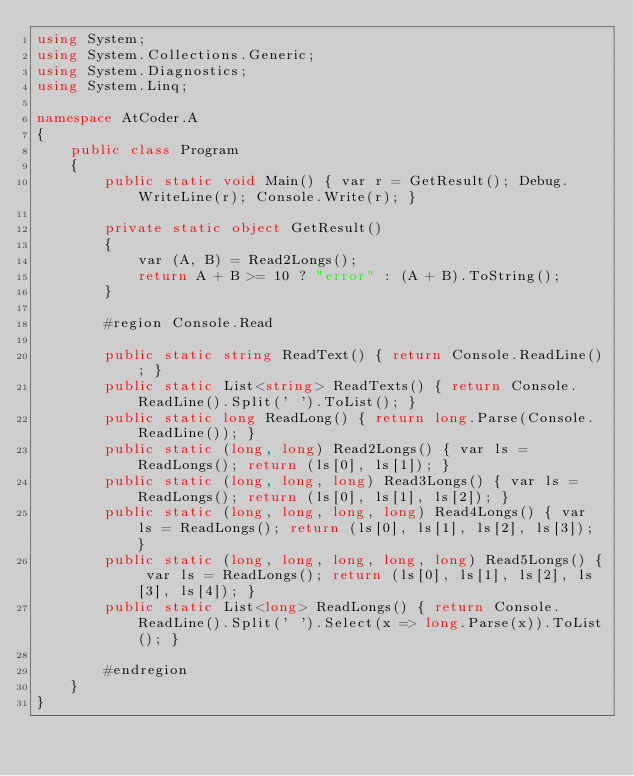Convert code to text. <code><loc_0><loc_0><loc_500><loc_500><_C#_>using System;
using System.Collections.Generic;
using System.Diagnostics;
using System.Linq;

namespace AtCoder.A
{
    public class Program
    {
        public static void Main() { var r = GetResult(); Debug.WriteLine(r); Console.Write(r); }

        private static object GetResult()
        {
            var (A, B) = Read2Longs();
            return A + B >= 10 ? "error" : (A + B).ToString();
        }

        #region Console.Read

        public static string ReadText() { return Console.ReadLine(); }
        public static List<string> ReadTexts() { return Console.ReadLine().Split(' ').ToList(); }
        public static long ReadLong() { return long.Parse(Console.ReadLine()); }
        public static (long, long) Read2Longs() { var ls = ReadLongs(); return (ls[0], ls[1]); }
        public static (long, long, long) Read3Longs() { var ls = ReadLongs(); return (ls[0], ls[1], ls[2]); }
        public static (long, long, long, long) Read4Longs() { var ls = ReadLongs(); return (ls[0], ls[1], ls[2], ls[3]); }
        public static (long, long, long, long, long) Read5Longs() { var ls = ReadLongs(); return (ls[0], ls[1], ls[2], ls[3], ls[4]); }
        public static List<long> ReadLongs() { return Console.ReadLine().Split(' ').Select(x => long.Parse(x)).ToList(); }

        #endregion
    }
}
</code> 